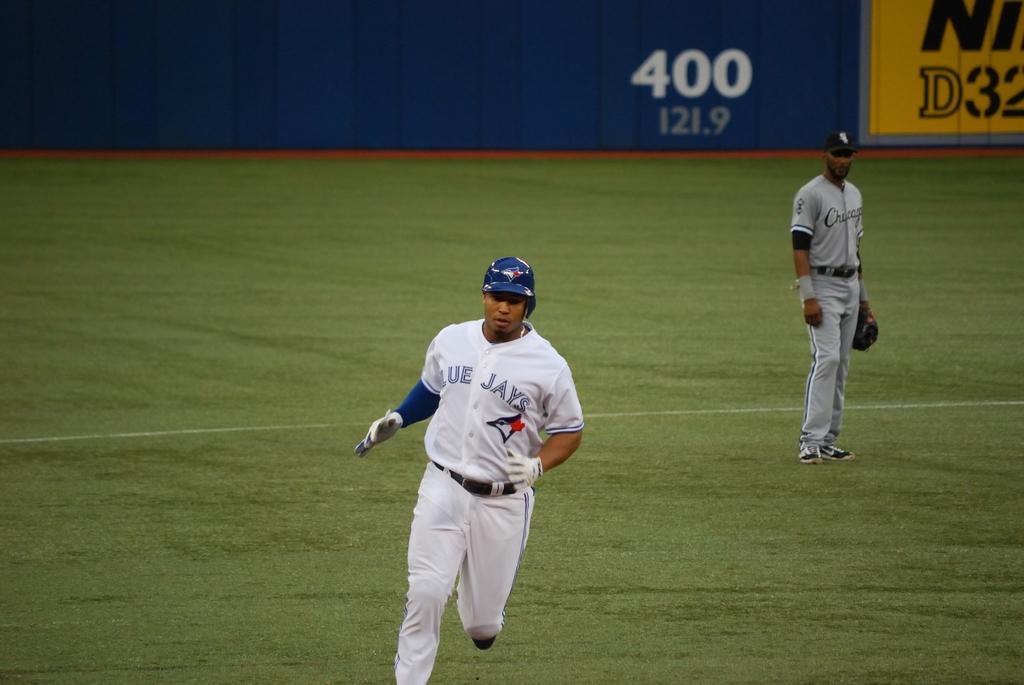What team is the runner on?
Your answer should be compact. Blue jays. 